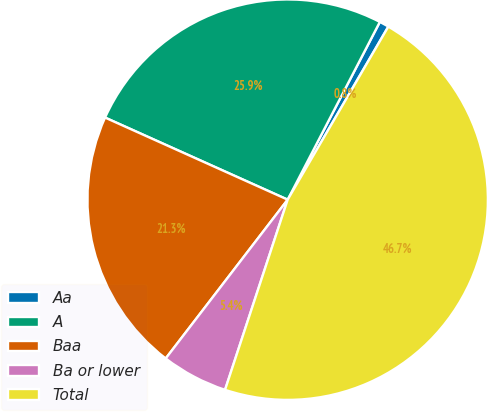<chart> <loc_0><loc_0><loc_500><loc_500><pie_chart><fcel>Aa<fcel>A<fcel>Baa<fcel>Ba or lower<fcel>Total<nl><fcel>0.77%<fcel>25.89%<fcel>21.3%<fcel>5.36%<fcel>46.68%<nl></chart> 